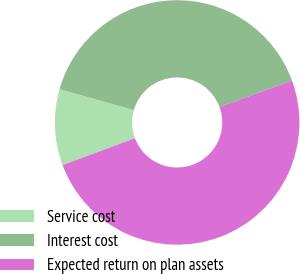Convert chart. <chart><loc_0><loc_0><loc_500><loc_500><pie_chart><fcel>Service cost<fcel>Interest cost<fcel>Expected return on plan assets<nl><fcel>10.07%<fcel>40.03%<fcel>49.9%<nl></chart> 